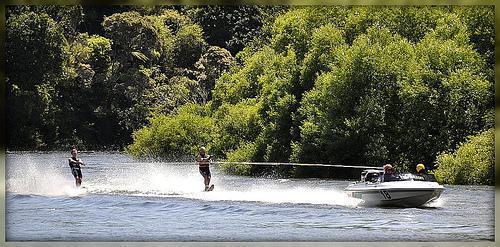How many skiers can be seen?
Give a very brief answer. 2. 